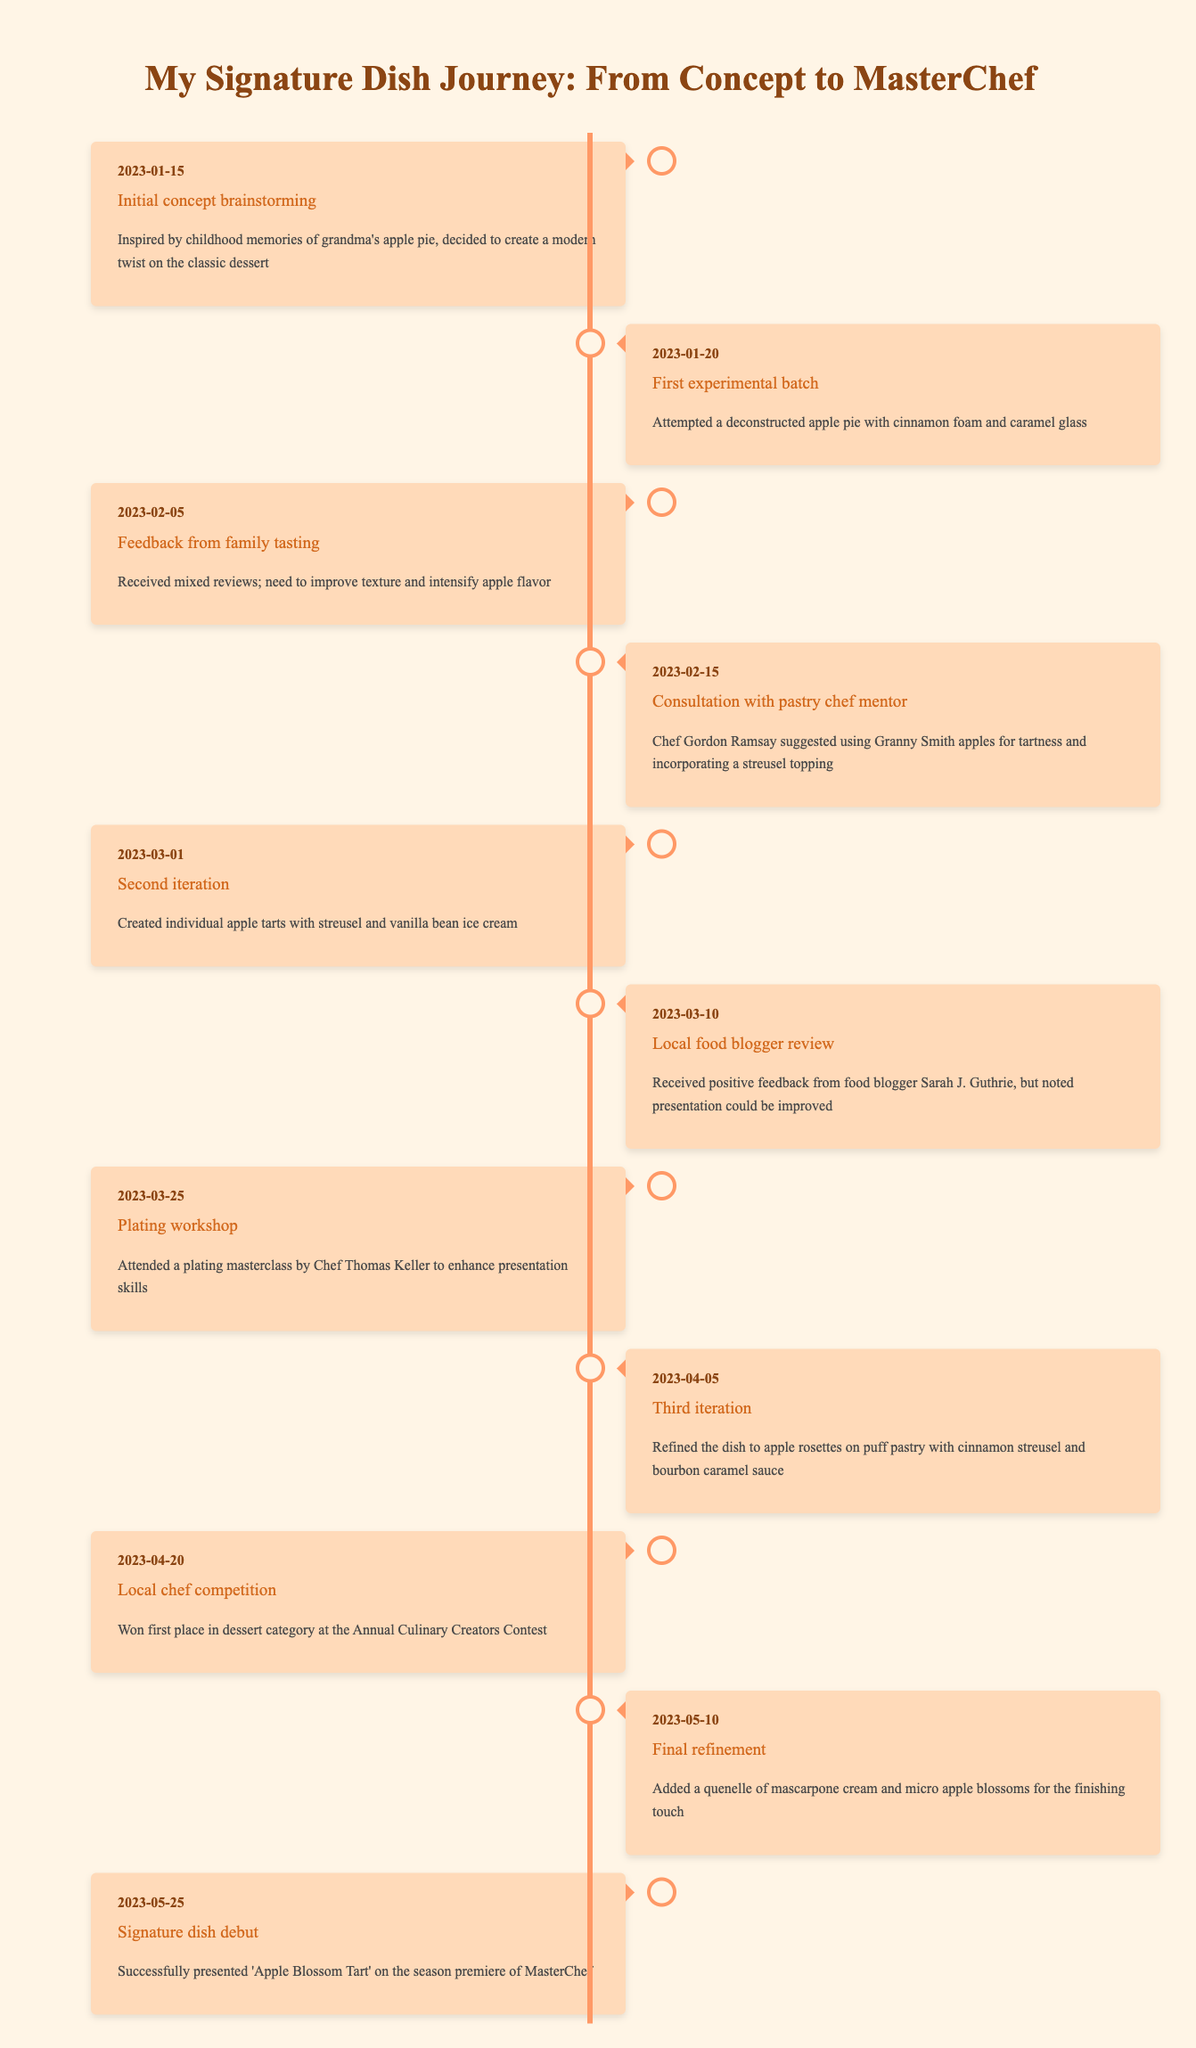What date did the initial concept brainstorming occur? The table lists the event "Initial concept brainstorming" along with its date, which is 2023-01-15.
Answer: 2023-01-15 What was the main suggestion from Chef Gordon Ramsay? The description for the event "Consultation with pastry chef mentor" states that Chef Gordon Ramsay suggested using Granny Smith apples for tartness and incorporating a streusel topping.
Answer: Use Granny Smith apples and incorporate a streusel topping In how many iterations was the dish refined before the final version was presented? The timeline shows three iterations: the first was the experimental batch, the second was the creation of individual apple tarts, and the third iteration refined the dish to apple rosettes. Thus, there were three iterations before the final version.
Answer: Three iterations Did the local food blogger give a positive review? The event "Local food blogger review" states that the blogger received positive feedback, so the answer to whether the review was positive is yes.
Answer: Yes What changes were made to the dish on 2023-05-10 during the final refinement? The final refinement event describes that a quenelle of mascarpone cream and micro apple blossoms were added to the dish, indicating specific enhancements made to its presentation.
Answer: Added mascarpone cream and micro apple blossoms What is the relationship between the date of the signature dish debut and the local chef competition? The signature dish debut occurred on 2023-05-25 and the local chef competition was on 2023-04-20. The difference in dates is 35 days, indicating that the debut happened significantly after the competition.
Answer: 35 days later Which event received mixed reviews regarding texture and flavor? The event labeled "Feedback from family tasting" notes that there were mixed reviews, specifically stating a need to improve texture and intensify apple flavor.
Answer: Feedback from family tasting What percentage of the significant events include consultation or feedback? There are 11 events in total. The events related to consultation or feedback include the family tasting feedback, and the consultation with the pastry chef mentor. That totals to 2 events, thus the percentage is (2/11) * 100 = 18.18%.
Answer: 18.18% What was the last enhancement made to the dish before its debut? The table indicates that on 2023-05-10, the final refinement added mascarpone cream and micro apple blossoms. This was the last recorded enhancement before the signature dish's debut.
Answer: Added mascarpone cream and micro apple blossoms 